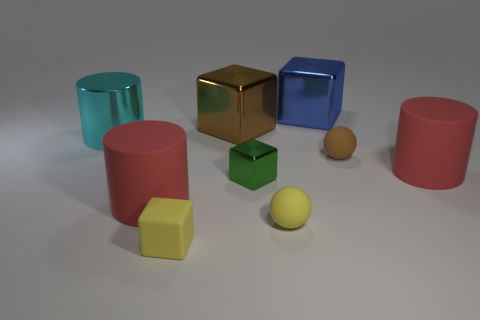Add 1 brown things. How many objects exist? 10 Subtract all balls. How many objects are left? 7 Subtract all metal cubes. Subtract all green metal blocks. How many objects are left? 5 Add 4 yellow matte blocks. How many yellow matte blocks are left? 5 Add 4 small rubber spheres. How many small rubber spheres exist? 6 Subtract 0 yellow cylinders. How many objects are left? 9 